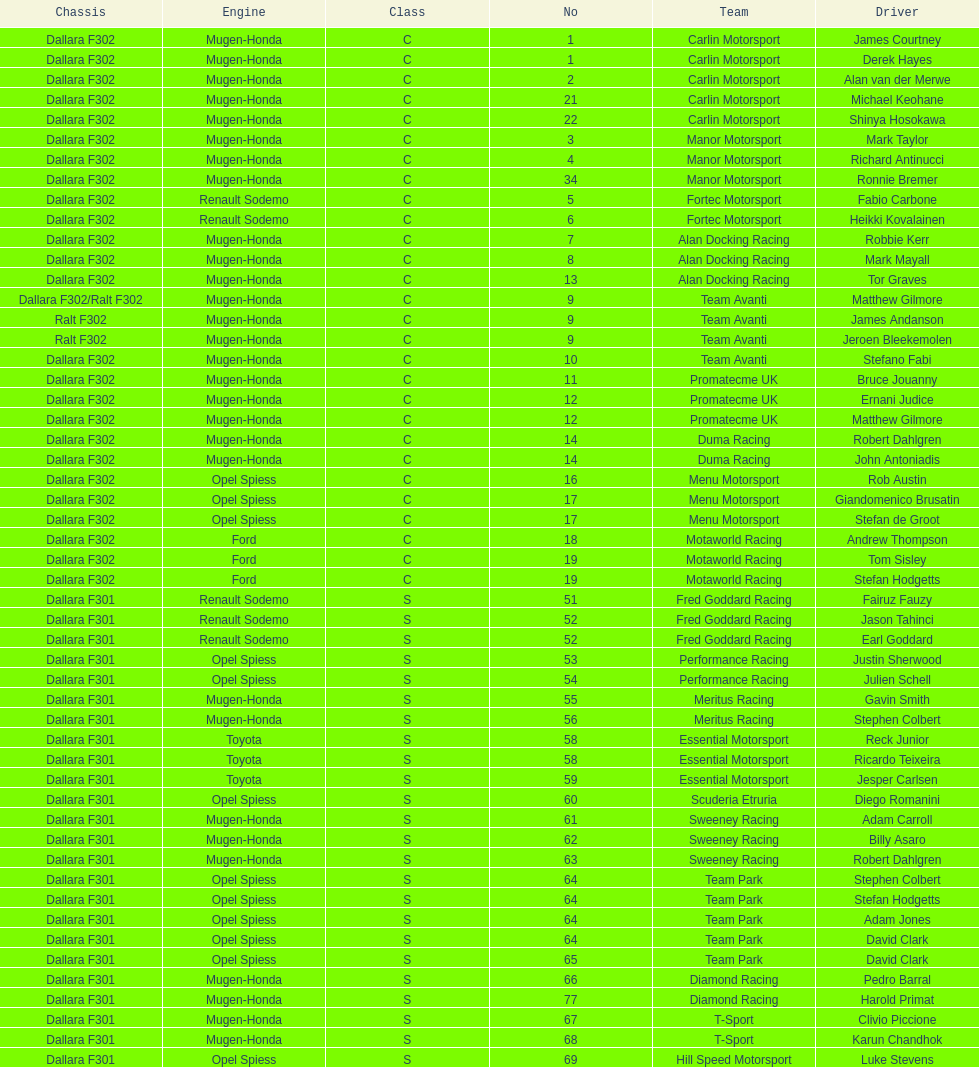How many teams had at least two drivers this season? 17. 